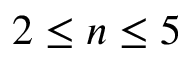<formula> <loc_0><loc_0><loc_500><loc_500>2 \leq n \leq 5</formula> 